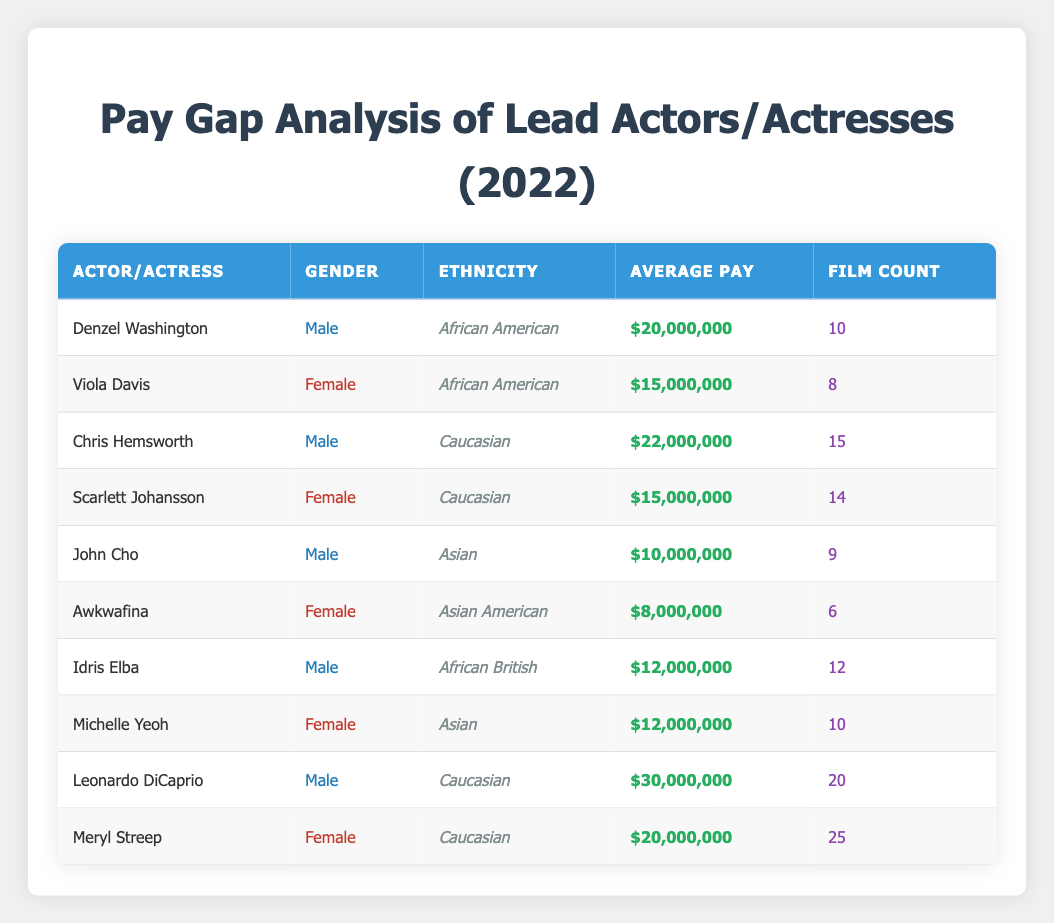What is the highest average pay among the actors listed? Looking at the average pay for all actors, Leonardo DiCaprio has the highest pay at $30,000,000.
Answer: $30,000,000 What is the average pay of female actors in the list? The female actors are Viola Davis ($15,000,000), Scarlett Johansson ($15,000,000), Awkwafina ($8,000,000), Michelle Yeoh ($12,000,000), and Meryl Streep ($20,000,000). The total pay is $15M + $15M + $8M + $12M + $20M = $70M. There are 5 female actors, so the average pay is $70M / 5 = $14M.
Answer: $14,000,000 Is Chris Hemsworth's average pay higher than Idris Elba's? Chris Hemsworth's average pay is $22,000,000, while Idris Elba's average pay is $12,000,000. Therefore, Chris Hemsworth's pay is higher.
Answer: Yes How many films did the male actors collectively appear in? The male actors are Denzel Washington (10 films), Chris Hemsworth (15 films), John Cho (9 films), Idris Elba (12 films), and Leonardo DiCaprio (20 films). The total film count is 10 + 15 + 9 + 12 + 20 = 66 films.
Answer: 66 What is the pay gap between the highest-paid male actor and the highest-paid female actor? The highest-paid male actor is Leonardo DiCaprio with $30,000,000, and the highest-paid female actor is Meryl Streep with $20,000,000. The pay gap is $30M - $20M = $10M.
Answer: $10,000,000 Which ethnicity has the lowest average pay among the male actors? The male actors and their pays are as follows: Denzel Washington ($20,000,000), Chris Hemsworth ($22,000,000), John Cho ($10,000,000), Idris Elba ($12,000,000), and Leonardo DiCaprio ($30,000,000). The lowest is John Cho at $10,000,000.
Answer: Asian What are the average pays for both Caucasian and African American actors? For Caucasian actors (Chris Hemsworth: $22M, Scarlett Johansson: $15M, Leonardo DiCaprio: $30M, Meryl Streep: $20M), the total pay is $22M + $15M + $30M + $20M = $87M for 4 actors, averaging $21.75M. For African American actors (Denzel Washington: $20M, Viola Davis: $15M, Idris Elba: $12M), the total pay is $20M + $15M + $12M = $47M for 3 actors, averaging $15.67M.
Answer: Caucasian: $21,750,000; African American: $15,666,667 Are there more films associated with female actors than with male actors in total? The total film count for female actors is 8 (Viola Davis) + 14 (Scarlett Johansson) + 6 (Awkwafina) + 10 (Michelle Yeoh) + 25 (Meryl Streep) = 63 films. Male actors have 66 films. Thus, male actors have more films.
Answer: No 